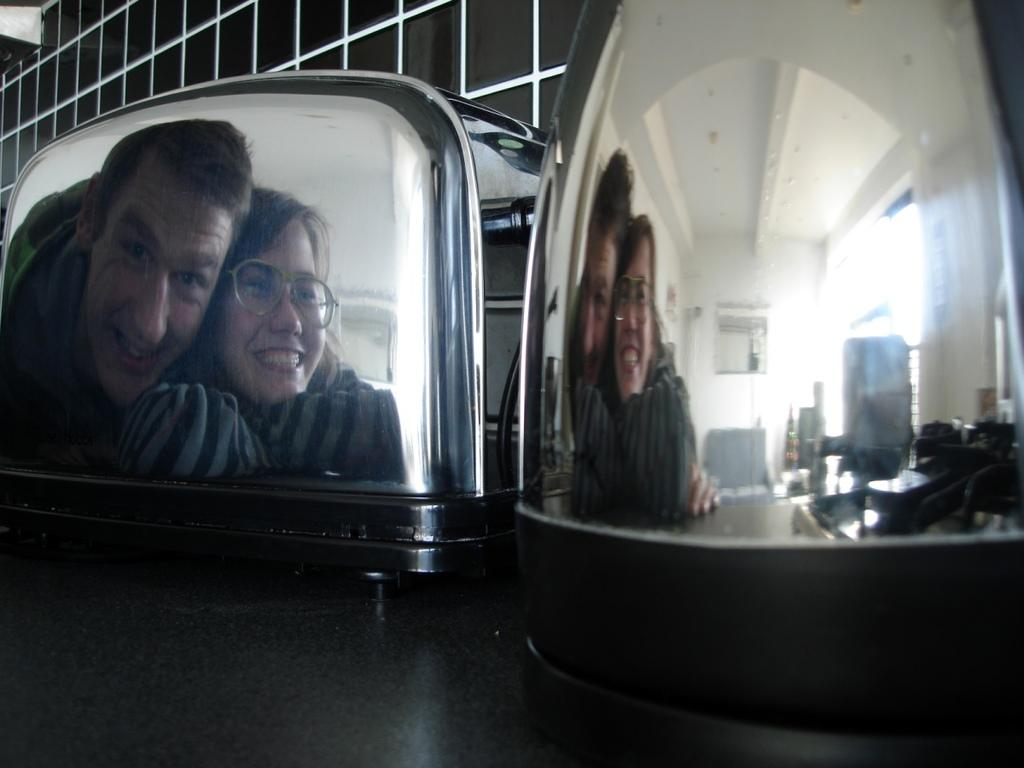What type of objects are present in the image? There are still objects in the image. Can you describe the reflection visible in the image? The reflection of two people is visible in the image. What is located above the objects in the image? There is a ceiling with objects on it in the image. What can be seen in the background of the image? There is a wall in the background of the image. What type of humor can be seen in the image? There is no humor present in the image; it features still objects and a reflection of two people. Can you tell me how many people are driving in the image? There is no driving activity depicted in the image. 